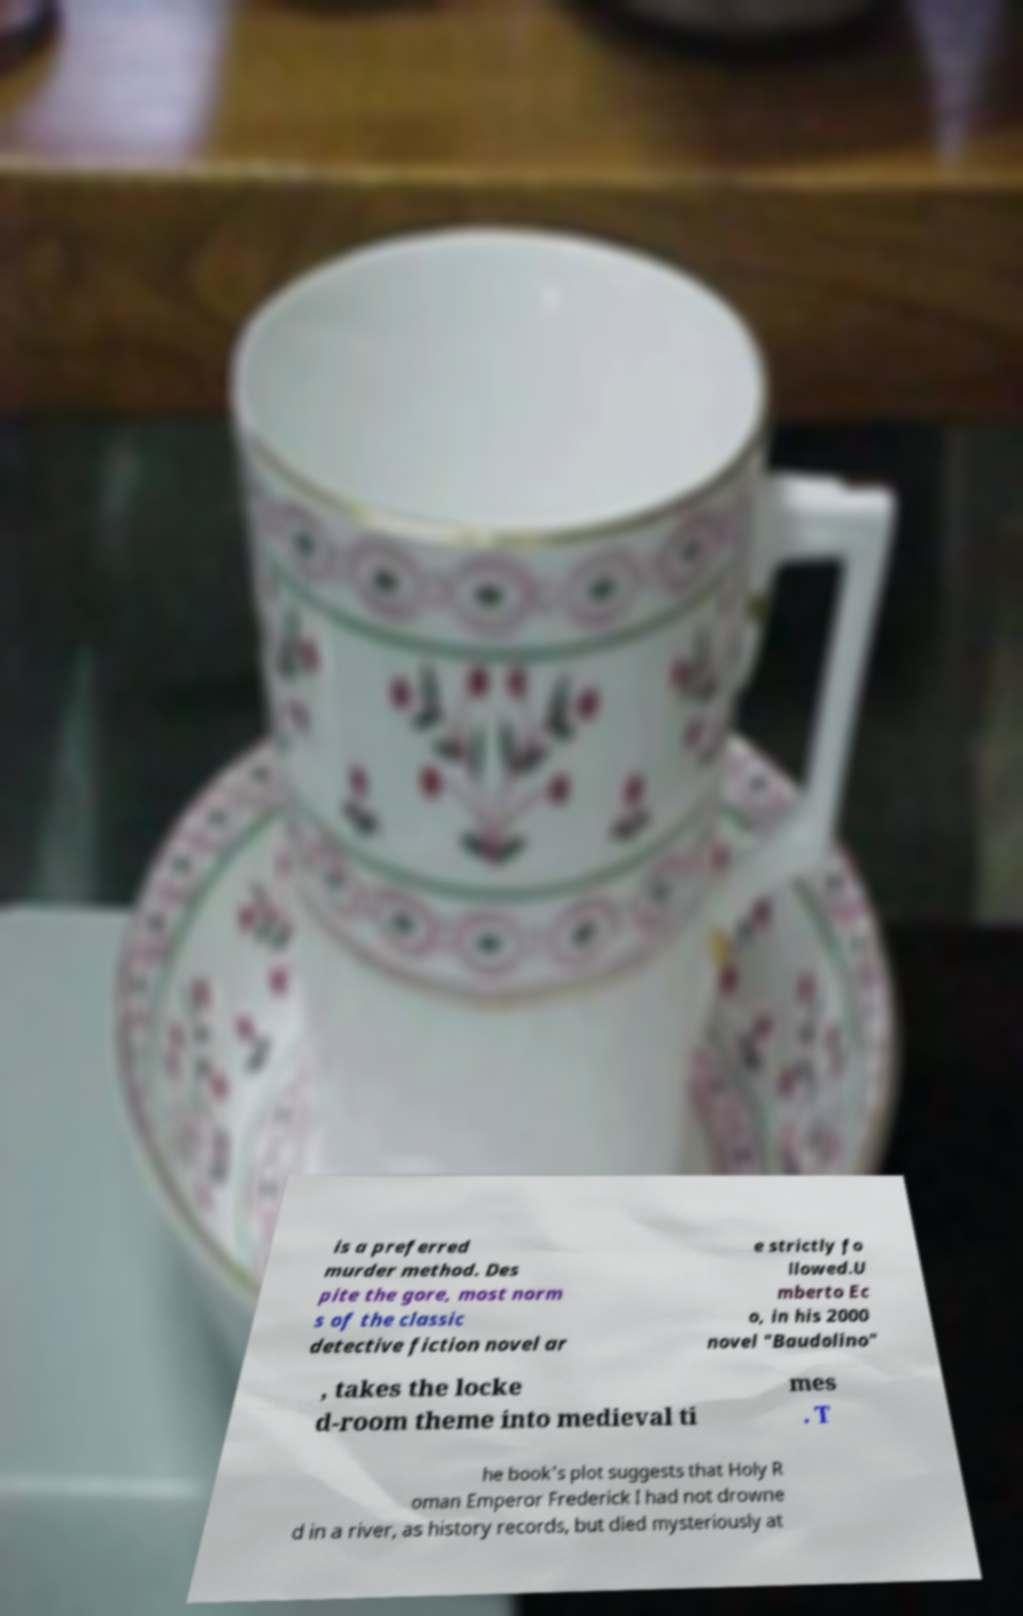There's text embedded in this image that I need extracted. Can you transcribe it verbatim? is a preferred murder method. Des pite the gore, most norm s of the classic detective fiction novel ar e strictly fo llowed.U mberto Ec o, in his 2000 novel "Baudolino" , takes the locke d-room theme into medieval ti mes . T he book's plot suggests that Holy R oman Emperor Frederick I had not drowne d in a river, as history records, but died mysteriously at 